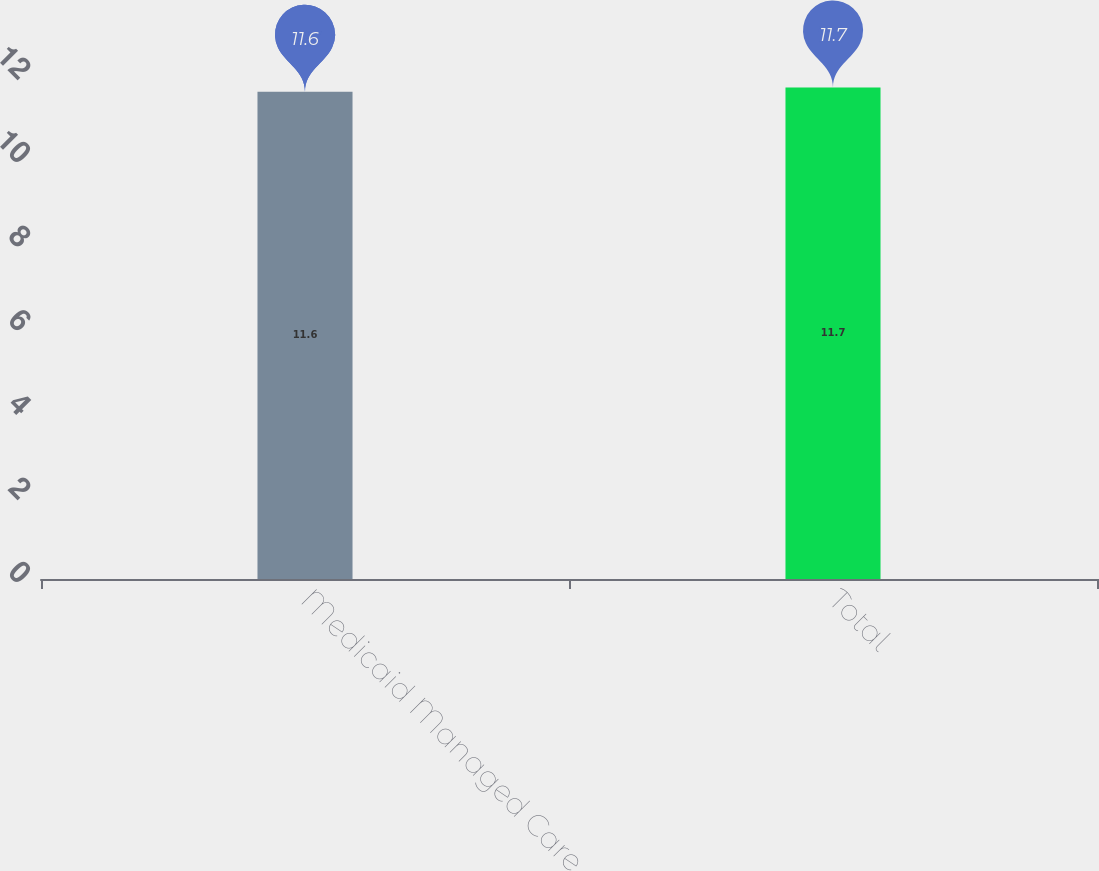Convert chart to OTSL. <chart><loc_0><loc_0><loc_500><loc_500><bar_chart><fcel>Medicaid Managed Care<fcel>Total<nl><fcel>11.6<fcel>11.7<nl></chart> 